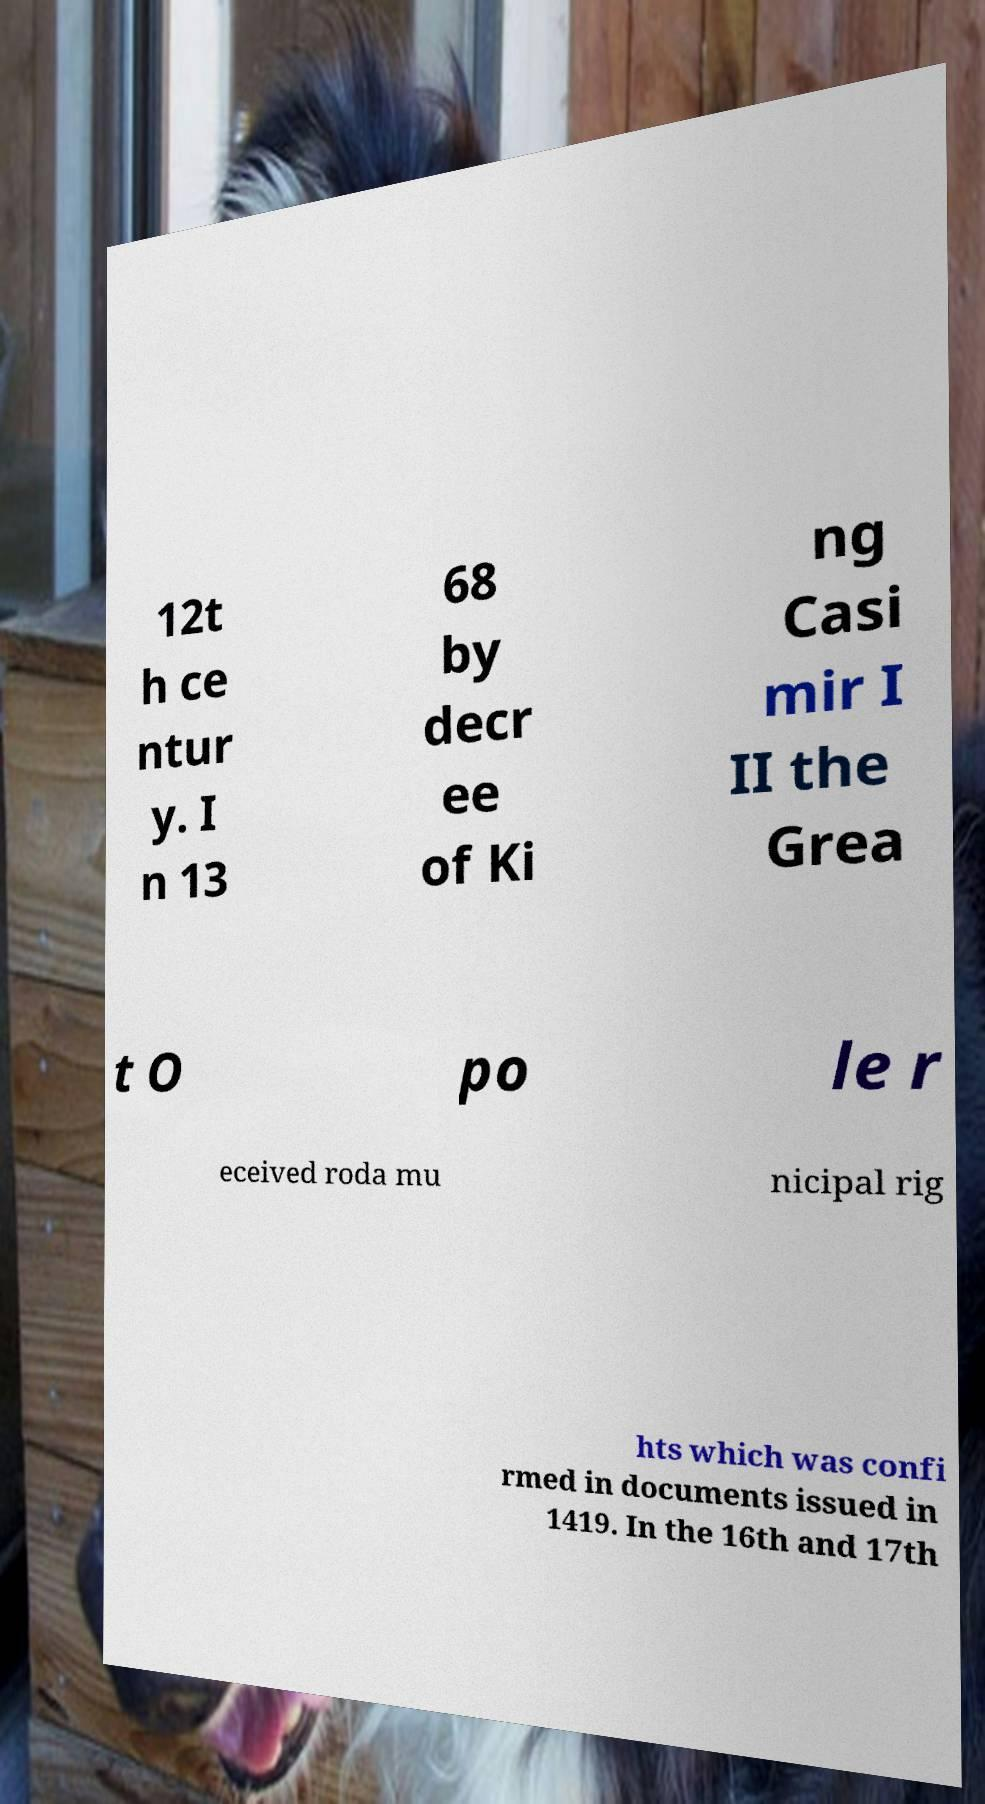Can you accurately transcribe the text from the provided image for me? 12t h ce ntur y. I n 13 68 by decr ee of Ki ng Casi mir I II the Grea t O po le r eceived roda mu nicipal rig hts which was confi rmed in documents issued in 1419. In the 16th and 17th 